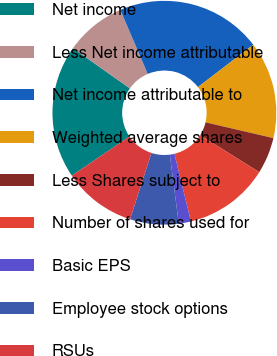<chart> <loc_0><loc_0><loc_500><loc_500><pie_chart><fcel>Net income<fcel>Less Net income attributable<fcel>Net income attributable to<fcel>Weighted average shares<fcel>Less Shares subject to<fcel>Number of shares used for<fcel>Basic EPS<fcel>Employee stock options<fcel>RSUs<nl><fcel>19.29%<fcel>8.77%<fcel>21.05%<fcel>14.03%<fcel>5.27%<fcel>12.28%<fcel>1.76%<fcel>7.02%<fcel>10.53%<nl></chart> 